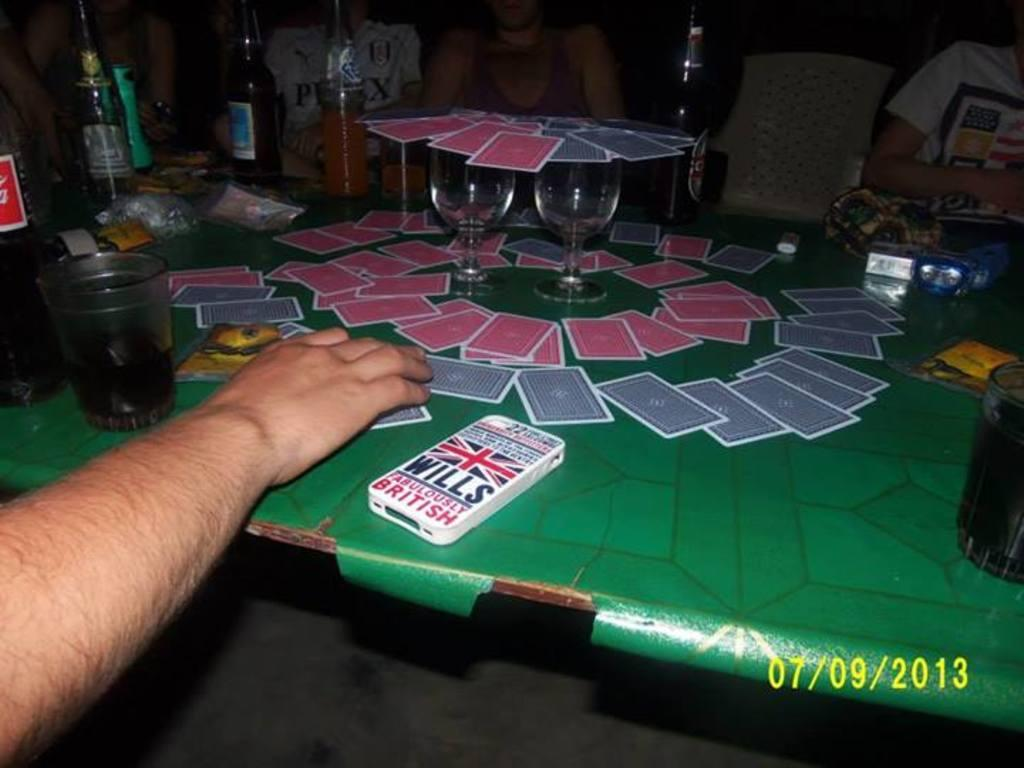What body part is visible in the image? There is a human hand in the image. What type of furniture is present in the image? There is a table in the image. What items can be seen on the table? There are cards, glasses, and bottles on the table. How many sheets of paper are on the table in the image? There is no paper visible on the table in the image. Can you see anyone stepping on the cards in the image? There is no one stepping on the cards in the image. 